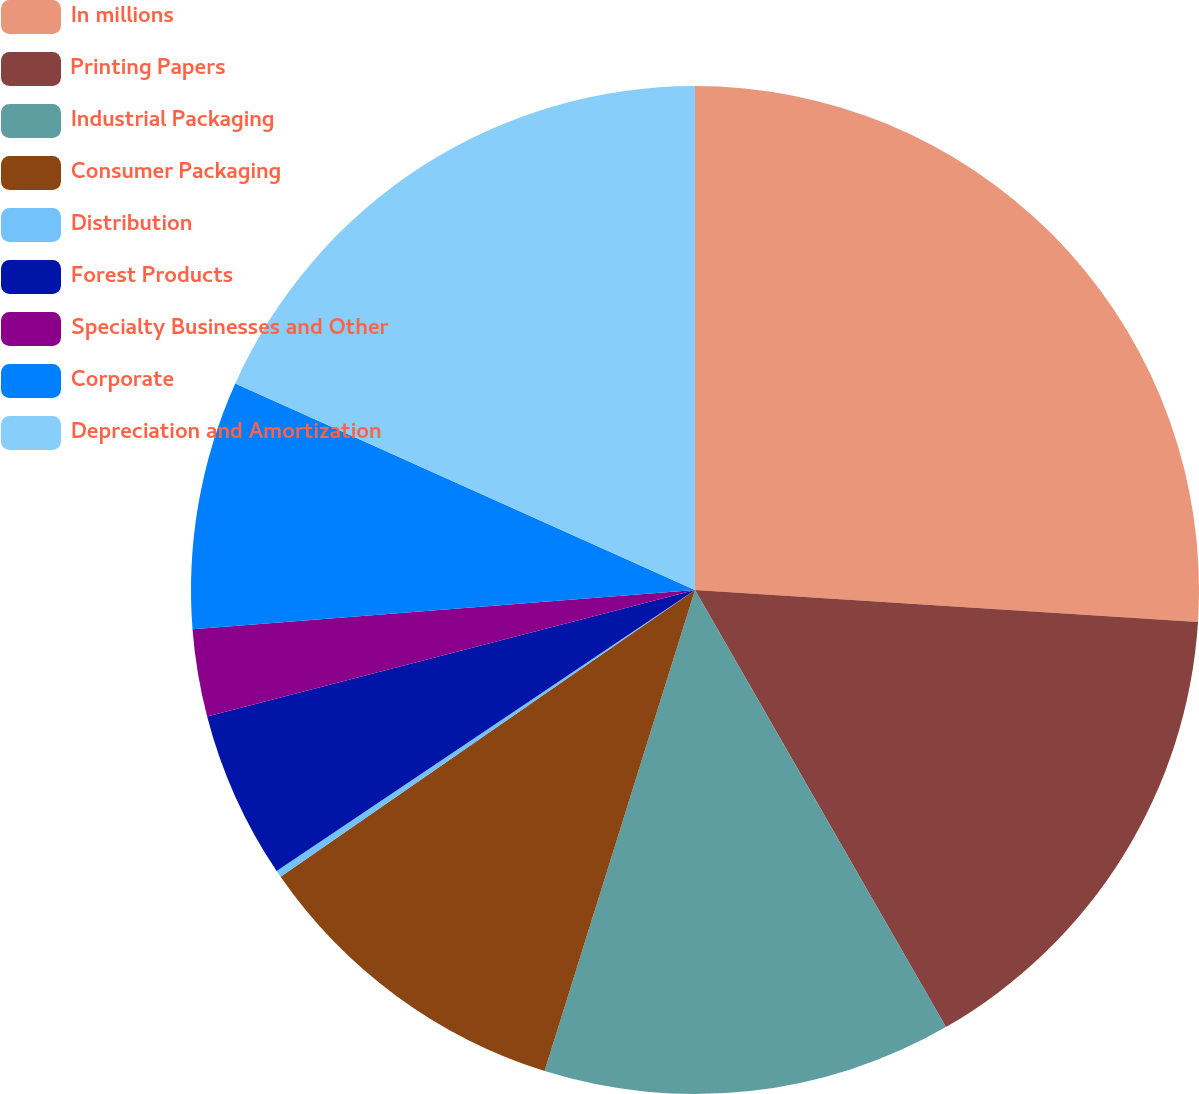<chart> <loc_0><loc_0><loc_500><loc_500><pie_chart><fcel>In millions<fcel>Printing Papers<fcel>Industrial Packaging<fcel>Consumer Packaging<fcel>Distribution<fcel>Forest Products<fcel>Specialty Businesses and Other<fcel>Corporate<fcel>Depreciation and Amortization<nl><fcel>26.01%<fcel>15.7%<fcel>13.12%<fcel>10.54%<fcel>0.22%<fcel>5.38%<fcel>2.8%<fcel>7.96%<fcel>18.28%<nl></chart> 